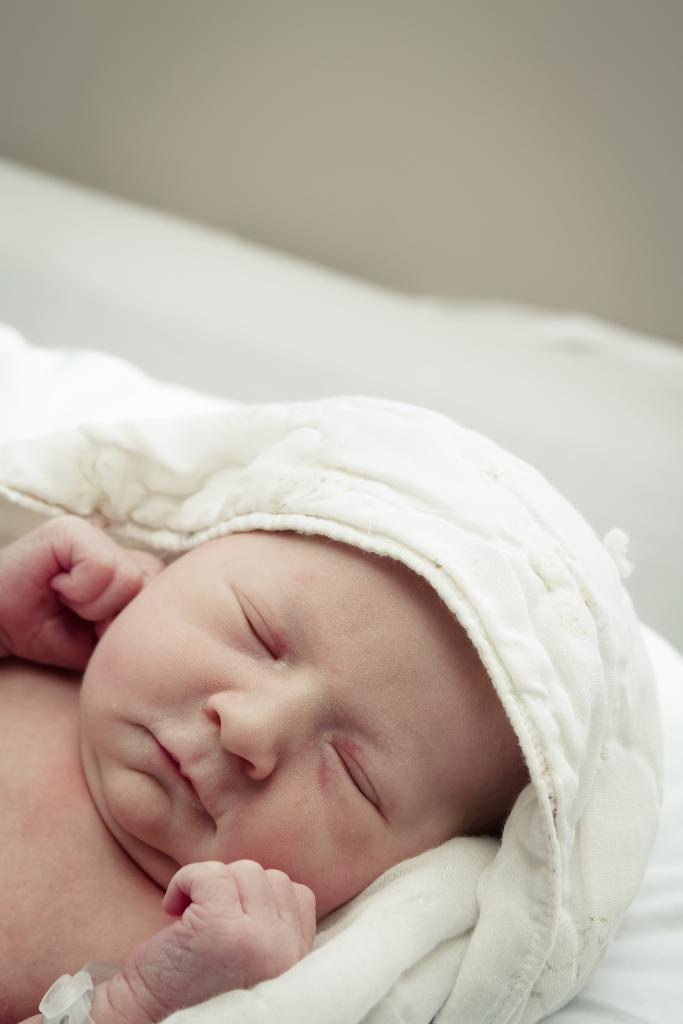What is the main subject of the image? There is a baby in the image. What is covering the baby in the image? There is a blanket in the image. Can you describe the background of the image? The background of the image is blurred. What type of rose can be seen in the baby's hand in the image? There is no rose present in the image; the baby is not holding anything. What is the cause of the baby's laughter in the image? The image does not show the baby laughing, nor does it provide any information about the baby's emotions. 